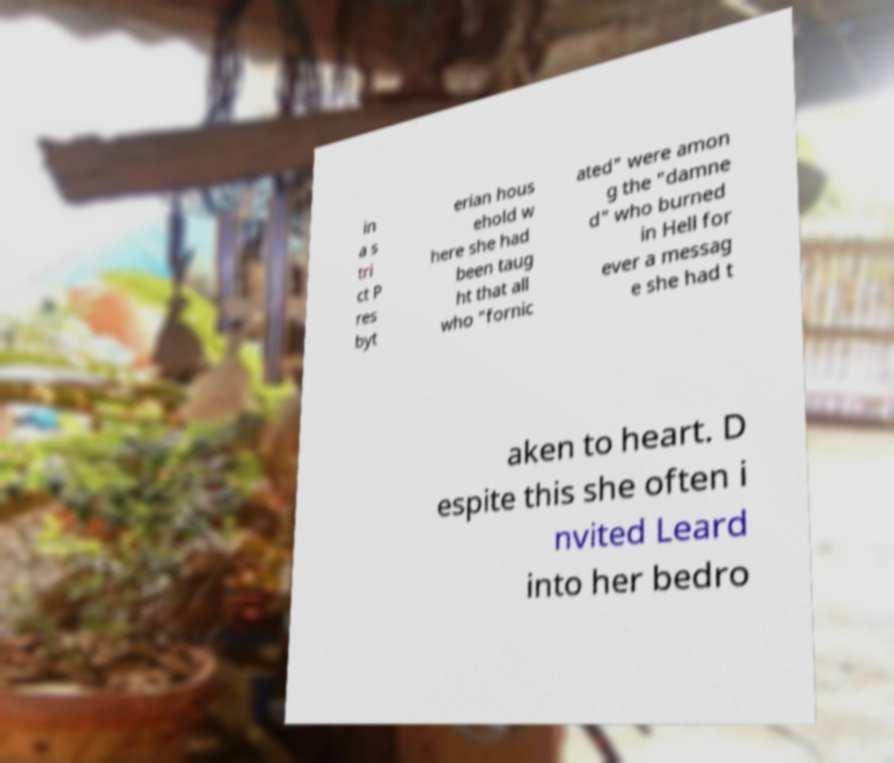Could you extract and type out the text from this image? in a s tri ct P res byt erian hous ehold w here she had been taug ht that all who "fornic ated" were amon g the "damne d" who burned in Hell for ever a messag e she had t aken to heart. D espite this she often i nvited Leard into her bedro 